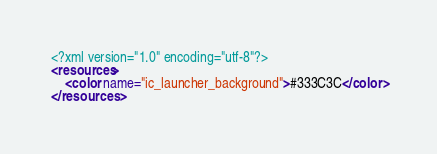<code> <loc_0><loc_0><loc_500><loc_500><_XML_><?xml version="1.0" encoding="utf-8"?>
<resources>
    <color name="ic_launcher_background">#333C3C</color>
</resources></code> 